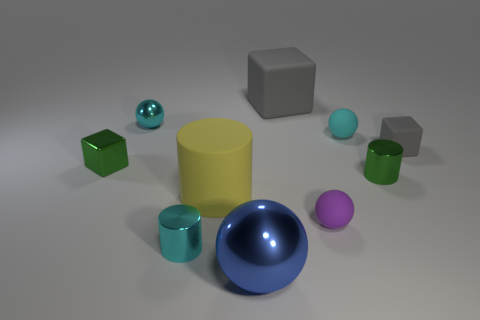How many objects are there in total, and can you categorize them by color? There are nine objects in total. Categorizing by color, there are two blue objects, two green objects, three gray objects, one yellow object, and one purple object. 